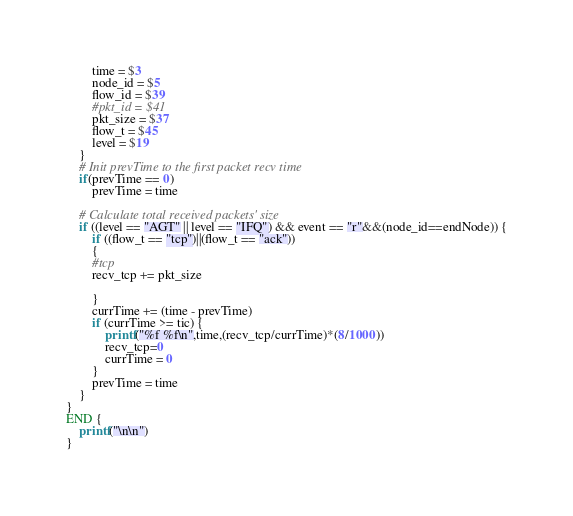<code> <loc_0><loc_0><loc_500><loc_500><_Awk_>		time = $3
		node_id = $5
		flow_id = $39
		#pkt_id = $41
		pkt_size = $37
		flow_t = $45
		level = $19
	}
	# Init prevTime to the first packet recv time
	if(prevTime == 0)
		prevTime = time

	# Calculate total received packets' size
	if ((level == "AGT" || level == "IFQ") && event == "r"&&(node_id==endNode)) {
	    if ((flow_t == "tcp")||(flow_t == "ack"))
	    {
	    #tcp
	    recv_tcp += pkt_size
	    
	    }
	    currTime += (time - prevTime)  
	    if (currTime >= tic) {
            printf("%f %f\n",time,(recv_tcp/currTime)*(8/1000))         
	        recv_tcp=0
	        currTime = 0    
		}
		prevTime = time
	}
}
END {
	printf("\n\n")
}
</code> 